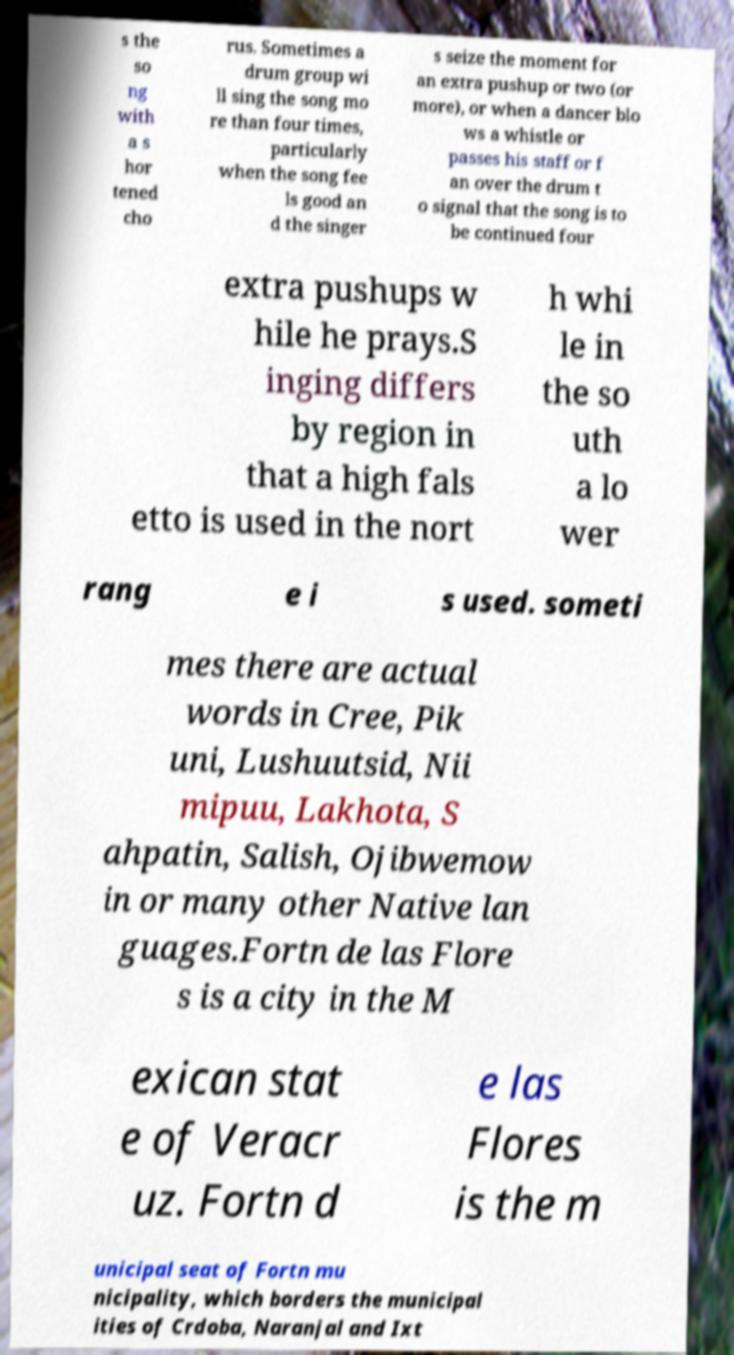Could you assist in decoding the text presented in this image and type it out clearly? s the so ng with a s hor tened cho rus. Sometimes a drum group wi ll sing the song mo re than four times, particularly when the song fee ls good an d the singer s seize the moment for an extra pushup or two (or more), or when a dancer blo ws a whistle or passes his staff or f an over the drum t o signal that the song is to be continued four extra pushups w hile he prays.S inging differs by region in that a high fals etto is used in the nort h whi le in the so uth a lo wer rang e i s used. someti mes there are actual words in Cree, Pik uni, Lushuutsid, Nii mipuu, Lakhota, S ahpatin, Salish, Ojibwemow in or many other Native lan guages.Fortn de las Flore s is a city in the M exican stat e of Veracr uz. Fortn d e las Flores is the m unicipal seat of Fortn mu nicipality, which borders the municipal ities of Crdoba, Naranjal and Ixt 